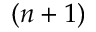<formula> <loc_0><loc_0><loc_500><loc_500>( n + 1 )</formula> 